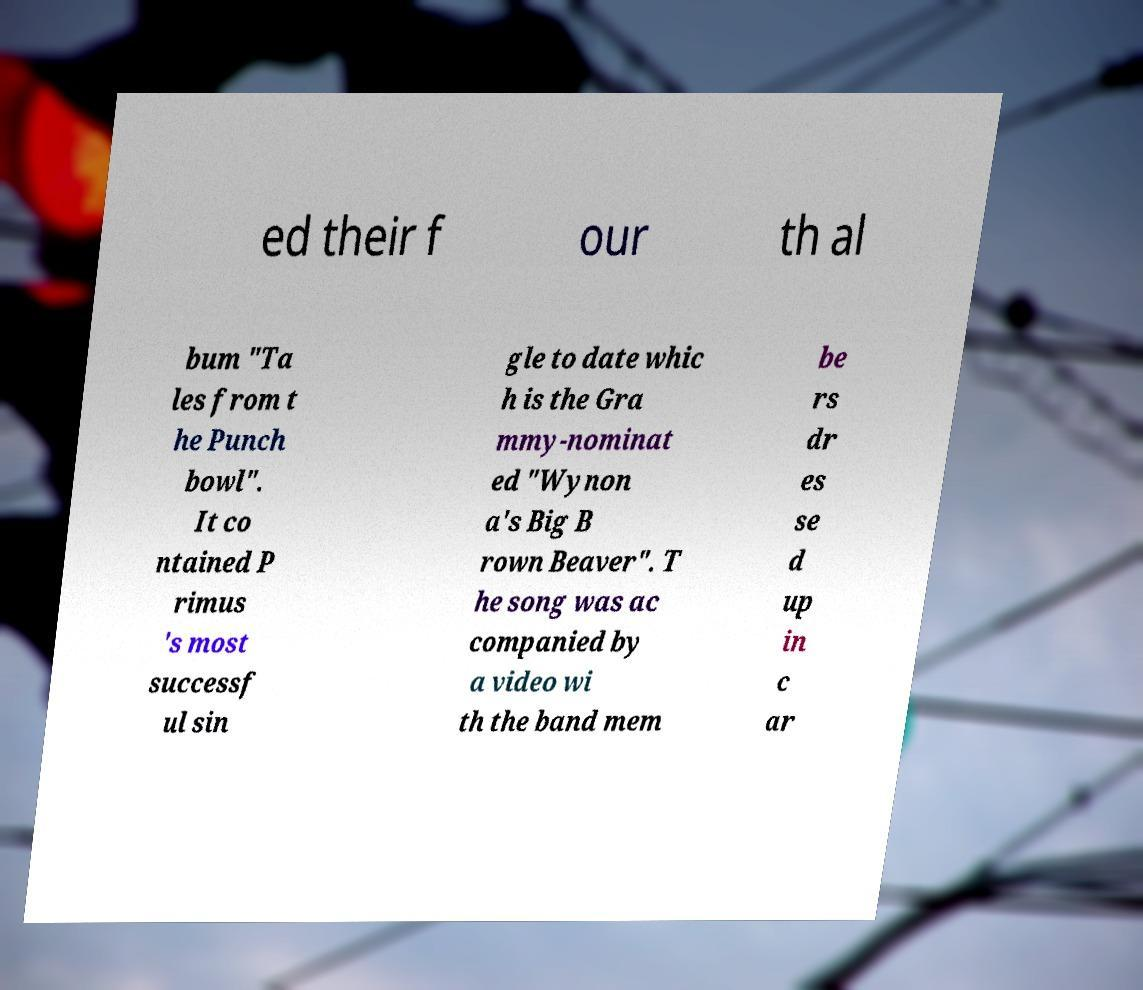Can you read and provide the text displayed in the image?This photo seems to have some interesting text. Can you extract and type it out for me? ed their f our th al bum "Ta les from t he Punch bowl". It co ntained P rimus 's most successf ul sin gle to date whic h is the Gra mmy-nominat ed "Wynon a's Big B rown Beaver". T he song was ac companied by a video wi th the band mem be rs dr es se d up in c ar 